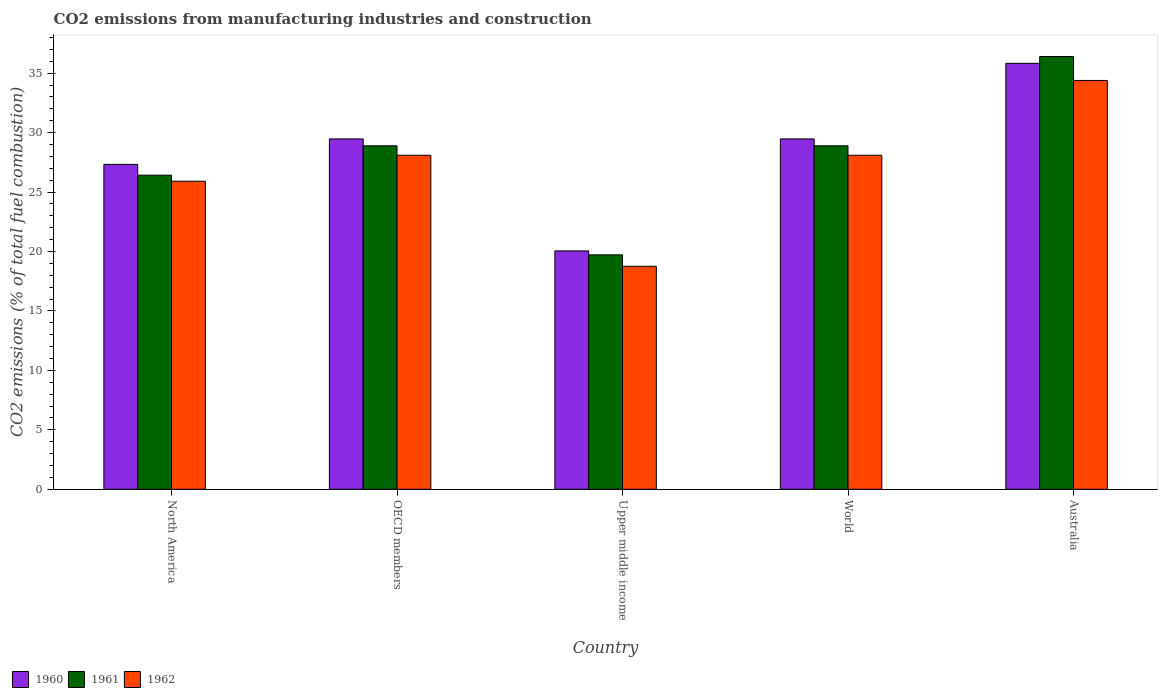How many groups of bars are there?
Keep it short and to the point. 5. Are the number of bars per tick equal to the number of legend labels?
Offer a terse response. Yes. Are the number of bars on each tick of the X-axis equal?
Your response must be concise. Yes. What is the amount of CO2 emitted in 1960 in Upper middle income?
Offer a terse response. 20.05. Across all countries, what is the maximum amount of CO2 emitted in 1961?
Give a very brief answer. 36.4. Across all countries, what is the minimum amount of CO2 emitted in 1961?
Give a very brief answer. 19.72. In which country was the amount of CO2 emitted in 1962 maximum?
Offer a terse response. Australia. In which country was the amount of CO2 emitted in 1960 minimum?
Your response must be concise. Upper middle income. What is the total amount of CO2 emitted in 1961 in the graph?
Your answer should be compact. 140.31. What is the difference between the amount of CO2 emitted in 1960 in Australia and that in World?
Offer a very short reply. 6.36. What is the difference between the amount of CO2 emitted in 1961 in North America and the amount of CO2 emitted in 1960 in Australia?
Your answer should be very brief. -9.41. What is the average amount of CO2 emitted in 1960 per country?
Offer a very short reply. 28.43. What is the difference between the amount of CO2 emitted of/in 1960 and amount of CO2 emitted of/in 1961 in OECD members?
Provide a succinct answer. 0.58. In how many countries, is the amount of CO2 emitted in 1961 greater than 26 %?
Make the answer very short. 4. What is the ratio of the amount of CO2 emitted in 1962 in Upper middle income to that in World?
Offer a terse response. 0.67. Is the difference between the amount of CO2 emitted in 1960 in OECD members and World greater than the difference between the amount of CO2 emitted in 1961 in OECD members and World?
Make the answer very short. No. What is the difference between the highest and the second highest amount of CO2 emitted in 1961?
Provide a short and direct response. 7.51. What is the difference between the highest and the lowest amount of CO2 emitted in 1961?
Your answer should be compact. 16.68. Is the sum of the amount of CO2 emitted in 1962 in Australia and Upper middle income greater than the maximum amount of CO2 emitted in 1961 across all countries?
Your answer should be very brief. Yes. What does the 1st bar from the right in OECD members represents?
Ensure brevity in your answer.  1962. How many countries are there in the graph?
Offer a terse response. 5. Are the values on the major ticks of Y-axis written in scientific E-notation?
Your answer should be very brief. No. Does the graph contain any zero values?
Provide a short and direct response. No. Does the graph contain grids?
Keep it short and to the point. No. How are the legend labels stacked?
Provide a short and direct response. Horizontal. What is the title of the graph?
Your answer should be very brief. CO2 emissions from manufacturing industries and construction. Does "1989" appear as one of the legend labels in the graph?
Make the answer very short. No. What is the label or title of the X-axis?
Provide a succinct answer. Country. What is the label or title of the Y-axis?
Offer a very short reply. CO2 emissions (% of total fuel combustion). What is the CO2 emissions (% of total fuel combustion) of 1960 in North America?
Your answer should be compact. 27.33. What is the CO2 emissions (% of total fuel combustion) of 1961 in North America?
Provide a short and direct response. 26.42. What is the CO2 emissions (% of total fuel combustion) of 1962 in North America?
Ensure brevity in your answer.  25.91. What is the CO2 emissions (% of total fuel combustion) of 1960 in OECD members?
Ensure brevity in your answer.  29.47. What is the CO2 emissions (% of total fuel combustion) of 1961 in OECD members?
Offer a very short reply. 28.89. What is the CO2 emissions (% of total fuel combustion) in 1962 in OECD members?
Your answer should be compact. 28.09. What is the CO2 emissions (% of total fuel combustion) in 1960 in Upper middle income?
Offer a terse response. 20.05. What is the CO2 emissions (% of total fuel combustion) of 1961 in Upper middle income?
Provide a short and direct response. 19.72. What is the CO2 emissions (% of total fuel combustion) in 1962 in Upper middle income?
Your answer should be very brief. 18.76. What is the CO2 emissions (% of total fuel combustion) of 1960 in World?
Offer a terse response. 29.47. What is the CO2 emissions (% of total fuel combustion) in 1961 in World?
Your answer should be very brief. 28.89. What is the CO2 emissions (% of total fuel combustion) of 1962 in World?
Provide a succinct answer. 28.09. What is the CO2 emissions (% of total fuel combustion) in 1960 in Australia?
Provide a short and direct response. 35.83. What is the CO2 emissions (% of total fuel combustion) in 1961 in Australia?
Provide a succinct answer. 36.4. What is the CO2 emissions (% of total fuel combustion) of 1962 in Australia?
Ensure brevity in your answer.  34.39. Across all countries, what is the maximum CO2 emissions (% of total fuel combustion) of 1960?
Give a very brief answer. 35.83. Across all countries, what is the maximum CO2 emissions (% of total fuel combustion) of 1961?
Give a very brief answer. 36.4. Across all countries, what is the maximum CO2 emissions (% of total fuel combustion) in 1962?
Offer a very short reply. 34.39. Across all countries, what is the minimum CO2 emissions (% of total fuel combustion) in 1960?
Your answer should be very brief. 20.05. Across all countries, what is the minimum CO2 emissions (% of total fuel combustion) of 1961?
Make the answer very short. 19.72. Across all countries, what is the minimum CO2 emissions (% of total fuel combustion) in 1962?
Offer a terse response. 18.76. What is the total CO2 emissions (% of total fuel combustion) in 1960 in the graph?
Ensure brevity in your answer.  142.14. What is the total CO2 emissions (% of total fuel combustion) in 1961 in the graph?
Give a very brief answer. 140.31. What is the total CO2 emissions (% of total fuel combustion) of 1962 in the graph?
Provide a succinct answer. 135.24. What is the difference between the CO2 emissions (% of total fuel combustion) in 1960 in North America and that in OECD members?
Your answer should be compact. -2.14. What is the difference between the CO2 emissions (% of total fuel combustion) of 1961 in North America and that in OECD members?
Your response must be concise. -2.47. What is the difference between the CO2 emissions (% of total fuel combustion) of 1962 in North America and that in OECD members?
Give a very brief answer. -2.18. What is the difference between the CO2 emissions (% of total fuel combustion) in 1960 in North America and that in Upper middle income?
Provide a succinct answer. 7.28. What is the difference between the CO2 emissions (% of total fuel combustion) of 1961 in North America and that in Upper middle income?
Provide a short and direct response. 6.7. What is the difference between the CO2 emissions (% of total fuel combustion) in 1962 in North America and that in Upper middle income?
Your response must be concise. 7.15. What is the difference between the CO2 emissions (% of total fuel combustion) of 1960 in North America and that in World?
Your answer should be very brief. -2.14. What is the difference between the CO2 emissions (% of total fuel combustion) of 1961 in North America and that in World?
Your answer should be very brief. -2.47. What is the difference between the CO2 emissions (% of total fuel combustion) of 1962 in North America and that in World?
Your answer should be very brief. -2.18. What is the difference between the CO2 emissions (% of total fuel combustion) of 1960 in North America and that in Australia?
Keep it short and to the point. -8.5. What is the difference between the CO2 emissions (% of total fuel combustion) in 1961 in North America and that in Australia?
Your answer should be very brief. -9.98. What is the difference between the CO2 emissions (% of total fuel combustion) in 1962 in North America and that in Australia?
Make the answer very short. -8.47. What is the difference between the CO2 emissions (% of total fuel combustion) of 1960 in OECD members and that in Upper middle income?
Offer a terse response. 9.42. What is the difference between the CO2 emissions (% of total fuel combustion) in 1961 in OECD members and that in Upper middle income?
Provide a succinct answer. 9.17. What is the difference between the CO2 emissions (% of total fuel combustion) in 1962 in OECD members and that in Upper middle income?
Your answer should be compact. 9.34. What is the difference between the CO2 emissions (% of total fuel combustion) in 1960 in OECD members and that in World?
Provide a short and direct response. 0. What is the difference between the CO2 emissions (% of total fuel combustion) of 1962 in OECD members and that in World?
Ensure brevity in your answer.  0. What is the difference between the CO2 emissions (% of total fuel combustion) in 1960 in OECD members and that in Australia?
Your answer should be compact. -6.36. What is the difference between the CO2 emissions (% of total fuel combustion) in 1961 in OECD members and that in Australia?
Provide a succinct answer. -7.51. What is the difference between the CO2 emissions (% of total fuel combustion) in 1962 in OECD members and that in Australia?
Offer a terse response. -6.29. What is the difference between the CO2 emissions (% of total fuel combustion) in 1960 in Upper middle income and that in World?
Provide a succinct answer. -9.42. What is the difference between the CO2 emissions (% of total fuel combustion) in 1961 in Upper middle income and that in World?
Give a very brief answer. -9.17. What is the difference between the CO2 emissions (% of total fuel combustion) of 1962 in Upper middle income and that in World?
Make the answer very short. -9.34. What is the difference between the CO2 emissions (% of total fuel combustion) in 1960 in Upper middle income and that in Australia?
Ensure brevity in your answer.  -15.78. What is the difference between the CO2 emissions (% of total fuel combustion) in 1961 in Upper middle income and that in Australia?
Your answer should be compact. -16.68. What is the difference between the CO2 emissions (% of total fuel combustion) in 1962 in Upper middle income and that in Australia?
Ensure brevity in your answer.  -15.63. What is the difference between the CO2 emissions (% of total fuel combustion) of 1960 in World and that in Australia?
Keep it short and to the point. -6.36. What is the difference between the CO2 emissions (% of total fuel combustion) of 1961 in World and that in Australia?
Your answer should be very brief. -7.51. What is the difference between the CO2 emissions (% of total fuel combustion) of 1962 in World and that in Australia?
Make the answer very short. -6.29. What is the difference between the CO2 emissions (% of total fuel combustion) in 1960 in North America and the CO2 emissions (% of total fuel combustion) in 1961 in OECD members?
Ensure brevity in your answer.  -1.56. What is the difference between the CO2 emissions (% of total fuel combustion) of 1960 in North America and the CO2 emissions (% of total fuel combustion) of 1962 in OECD members?
Your answer should be compact. -0.77. What is the difference between the CO2 emissions (% of total fuel combustion) in 1961 in North America and the CO2 emissions (% of total fuel combustion) in 1962 in OECD members?
Give a very brief answer. -1.67. What is the difference between the CO2 emissions (% of total fuel combustion) of 1960 in North America and the CO2 emissions (% of total fuel combustion) of 1961 in Upper middle income?
Provide a succinct answer. 7.61. What is the difference between the CO2 emissions (% of total fuel combustion) of 1960 in North America and the CO2 emissions (% of total fuel combustion) of 1962 in Upper middle income?
Give a very brief answer. 8.57. What is the difference between the CO2 emissions (% of total fuel combustion) in 1961 in North America and the CO2 emissions (% of total fuel combustion) in 1962 in Upper middle income?
Give a very brief answer. 7.66. What is the difference between the CO2 emissions (% of total fuel combustion) in 1960 in North America and the CO2 emissions (% of total fuel combustion) in 1961 in World?
Offer a terse response. -1.56. What is the difference between the CO2 emissions (% of total fuel combustion) of 1960 in North America and the CO2 emissions (% of total fuel combustion) of 1962 in World?
Provide a succinct answer. -0.77. What is the difference between the CO2 emissions (% of total fuel combustion) in 1961 in North America and the CO2 emissions (% of total fuel combustion) in 1962 in World?
Provide a short and direct response. -1.67. What is the difference between the CO2 emissions (% of total fuel combustion) in 1960 in North America and the CO2 emissions (% of total fuel combustion) in 1961 in Australia?
Make the answer very short. -9.07. What is the difference between the CO2 emissions (% of total fuel combustion) of 1960 in North America and the CO2 emissions (% of total fuel combustion) of 1962 in Australia?
Your answer should be compact. -7.06. What is the difference between the CO2 emissions (% of total fuel combustion) of 1961 in North America and the CO2 emissions (% of total fuel combustion) of 1962 in Australia?
Provide a succinct answer. -7.97. What is the difference between the CO2 emissions (% of total fuel combustion) in 1960 in OECD members and the CO2 emissions (% of total fuel combustion) in 1961 in Upper middle income?
Make the answer very short. 9.75. What is the difference between the CO2 emissions (% of total fuel combustion) in 1960 in OECD members and the CO2 emissions (% of total fuel combustion) in 1962 in Upper middle income?
Ensure brevity in your answer.  10.71. What is the difference between the CO2 emissions (% of total fuel combustion) of 1961 in OECD members and the CO2 emissions (% of total fuel combustion) of 1962 in Upper middle income?
Offer a terse response. 10.13. What is the difference between the CO2 emissions (% of total fuel combustion) in 1960 in OECD members and the CO2 emissions (% of total fuel combustion) in 1961 in World?
Your answer should be very brief. 0.58. What is the difference between the CO2 emissions (% of total fuel combustion) of 1960 in OECD members and the CO2 emissions (% of total fuel combustion) of 1962 in World?
Ensure brevity in your answer.  1.38. What is the difference between the CO2 emissions (% of total fuel combustion) in 1961 in OECD members and the CO2 emissions (% of total fuel combustion) in 1962 in World?
Your answer should be compact. 0.79. What is the difference between the CO2 emissions (% of total fuel combustion) in 1960 in OECD members and the CO2 emissions (% of total fuel combustion) in 1961 in Australia?
Provide a succinct answer. -6.93. What is the difference between the CO2 emissions (% of total fuel combustion) of 1960 in OECD members and the CO2 emissions (% of total fuel combustion) of 1962 in Australia?
Provide a succinct answer. -4.92. What is the difference between the CO2 emissions (% of total fuel combustion) of 1961 in OECD members and the CO2 emissions (% of total fuel combustion) of 1962 in Australia?
Your response must be concise. -5.5. What is the difference between the CO2 emissions (% of total fuel combustion) of 1960 in Upper middle income and the CO2 emissions (% of total fuel combustion) of 1961 in World?
Ensure brevity in your answer.  -8.84. What is the difference between the CO2 emissions (% of total fuel combustion) of 1960 in Upper middle income and the CO2 emissions (% of total fuel combustion) of 1962 in World?
Provide a short and direct response. -8.04. What is the difference between the CO2 emissions (% of total fuel combustion) of 1961 in Upper middle income and the CO2 emissions (% of total fuel combustion) of 1962 in World?
Offer a terse response. -8.38. What is the difference between the CO2 emissions (% of total fuel combustion) in 1960 in Upper middle income and the CO2 emissions (% of total fuel combustion) in 1961 in Australia?
Your response must be concise. -16.35. What is the difference between the CO2 emissions (% of total fuel combustion) in 1960 in Upper middle income and the CO2 emissions (% of total fuel combustion) in 1962 in Australia?
Your answer should be very brief. -14.34. What is the difference between the CO2 emissions (% of total fuel combustion) in 1961 in Upper middle income and the CO2 emissions (% of total fuel combustion) in 1962 in Australia?
Provide a short and direct response. -14.67. What is the difference between the CO2 emissions (% of total fuel combustion) of 1960 in World and the CO2 emissions (% of total fuel combustion) of 1961 in Australia?
Ensure brevity in your answer.  -6.93. What is the difference between the CO2 emissions (% of total fuel combustion) of 1960 in World and the CO2 emissions (% of total fuel combustion) of 1962 in Australia?
Your response must be concise. -4.92. What is the difference between the CO2 emissions (% of total fuel combustion) of 1961 in World and the CO2 emissions (% of total fuel combustion) of 1962 in Australia?
Offer a terse response. -5.5. What is the average CO2 emissions (% of total fuel combustion) of 1960 per country?
Provide a short and direct response. 28.43. What is the average CO2 emissions (% of total fuel combustion) of 1961 per country?
Keep it short and to the point. 28.06. What is the average CO2 emissions (% of total fuel combustion) of 1962 per country?
Ensure brevity in your answer.  27.05. What is the difference between the CO2 emissions (% of total fuel combustion) of 1960 and CO2 emissions (% of total fuel combustion) of 1961 in North America?
Ensure brevity in your answer.  0.91. What is the difference between the CO2 emissions (% of total fuel combustion) of 1960 and CO2 emissions (% of total fuel combustion) of 1962 in North America?
Provide a succinct answer. 1.42. What is the difference between the CO2 emissions (% of total fuel combustion) of 1961 and CO2 emissions (% of total fuel combustion) of 1962 in North America?
Give a very brief answer. 0.51. What is the difference between the CO2 emissions (% of total fuel combustion) of 1960 and CO2 emissions (% of total fuel combustion) of 1961 in OECD members?
Ensure brevity in your answer.  0.58. What is the difference between the CO2 emissions (% of total fuel combustion) in 1960 and CO2 emissions (% of total fuel combustion) in 1962 in OECD members?
Offer a terse response. 1.38. What is the difference between the CO2 emissions (% of total fuel combustion) of 1961 and CO2 emissions (% of total fuel combustion) of 1962 in OECD members?
Offer a terse response. 0.79. What is the difference between the CO2 emissions (% of total fuel combustion) in 1960 and CO2 emissions (% of total fuel combustion) in 1961 in Upper middle income?
Make the answer very short. 0.33. What is the difference between the CO2 emissions (% of total fuel combustion) of 1960 and CO2 emissions (% of total fuel combustion) of 1962 in Upper middle income?
Offer a very short reply. 1.29. What is the difference between the CO2 emissions (% of total fuel combustion) in 1961 and CO2 emissions (% of total fuel combustion) in 1962 in Upper middle income?
Your response must be concise. 0.96. What is the difference between the CO2 emissions (% of total fuel combustion) in 1960 and CO2 emissions (% of total fuel combustion) in 1961 in World?
Your response must be concise. 0.58. What is the difference between the CO2 emissions (% of total fuel combustion) of 1960 and CO2 emissions (% of total fuel combustion) of 1962 in World?
Provide a succinct answer. 1.38. What is the difference between the CO2 emissions (% of total fuel combustion) in 1961 and CO2 emissions (% of total fuel combustion) in 1962 in World?
Your response must be concise. 0.79. What is the difference between the CO2 emissions (% of total fuel combustion) of 1960 and CO2 emissions (% of total fuel combustion) of 1961 in Australia?
Your answer should be very brief. -0.57. What is the difference between the CO2 emissions (% of total fuel combustion) of 1960 and CO2 emissions (% of total fuel combustion) of 1962 in Australia?
Your answer should be compact. 1.44. What is the difference between the CO2 emissions (% of total fuel combustion) of 1961 and CO2 emissions (% of total fuel combustion) of 1962 in Australia?
Your response must be concise. 2.01. What is the ratio of the CO2 emissions (% of total fuel combustion) in 1960 in North America to that in OECD members?
Offer a terse response. 0.93. What is the ratio of the CO2 emissions (% of total fuel combustion) of 1961 in North America to that in OECD members?
Offer a terse response. 0.91. What is the ratio of the CO2 emissions (% of total fuel combustion) of 1962 in North America to that in OECD members?
Provide a succinct answer. 0.92. What is the ratio of the CO2 emissions (% of total fuel combustion) in 1960 in North America to that in Upper middle income?
Your answer should be very brief. 1.36. What is the ratio of the CO2 emissions (% of total fuel combustion) of 1961 in North America to that in Upper middle income?
Your response must be concise. 1.34. What is the ratio of the CO2 emissions (% of total fuel combustion) of 1962 in North America to that in Upper middle income?
Offer a very short reply. 1.38. What is the ratio of the CO2 emissions (% of total fuel combustion) in 1960 in North America to that in World?
Ensure brevity in your answer.  0.93. What is the ratio of the CO2 emissions (% of total fuel combustion) in 1961 in North America to that in World?
Provide a short and direct response. 0.91. What is the ratio of the CO2 emissions (% of total fuel combustion) in 1962 in North America to that in World?
Your answer should be compact. 0.92. What is the ratio of the CO2 emissions (% of total fuel combustion) in 1960 in North America to that in Australia?
Your response must be concise. 0.76. What is the ratio of the CO2 emissions (% of total fuel combustion) in 1961 in North America to that in Australia?
Your response must be concise. 0.73. What is the ratio of the CO2 emissions (% of total fuel combustion) of 1962 in North America to that in Australia?
Keep it short and to the point. 0.75. What is the ratio of the CO2 emissions (% of total fuel combustion) of 1960 in OECD members to that in Upper middle income?
Your answer should be compact. 1.47. What is the ratio of the CO2 emissions (% of total fuel combustion) of 1961 in OECD members to that in Upper middle income?
Ensure brevity in your answer.  1.47. What is the ratio of the CO2 emissions (% of total fuel combustion) in 1962 in OECD members to that in Upper middle income?
Your response must be concise. 1.5. What is the ratio of the CO2 emissions (% of total fuel combustion) of 1960 in OECD members to that in World?
Your answer should be very brief. 1. What is the ratio of the CO2 emissions (% of total fuel combustion) of 1960 in OECD members to that in Australia?
Provide a succinct answer. 0.82. What is the ratio of the CO2 emissions (% of total fuel combustion) in 1961 in OECD members to that in Australia?
Provide a succinct answer. 0.79. What is the ratio of the CO2 emissions (% of total fuel combustion) of 1962 in OECD members to that in Australia?
Make the answer very short. 0.82. What is the ratio of the CO2 emissions (% of total fuel combustion) in 1960 in Upper middle income to that in World?
Your answer should be very brief. 0.68. What is the ratio of the CO2 emissions (% of total fuel combustion) in 1961 in Upper middle income to that in World?
Your response must be concise. 0.68. What is the ratio of the CO2 emissions (% of total fuel combustion) in 1962 in Upper middle income to that in World?
Offer a very short reply. 0.67. What is the ratio of the CO2 emissions (% of total fuel combustion) of 1960 in Upper middle income to that in Australia?
Give a very brief answer. 0.56. What is the ratio of the CO2 emissions (% of total fuel combustion) in 1961 in Upper middle income to that in Australia?
Offer a very short reply. 0.54. What is the ratio of the CO2 emissions (% of total fuel combustion) in 1962 in Upper middle income to that in Australia?
Provide a succinct answer. 0.55. What is the ratio of the CO2 emissions (% of total fuel combustion) of 1960 in World to that in Australia?
Your answer should be very brief. 0.82. What is the ratio of the CO2 emissions (% of total fuel combustion) in 1961 in World to that in Australia?
Ensure brevity in your answer.  0.79. What is the ratio of the CO2 emissions (% of total fuel combustion) in 1962 in World to that in Australia?
Keep it short and to the point. 0.82. What is the difference between the highest and the second highest CO2 emissions (% of total fuel combustion) in 1960?
Provide a succinct answer. 6.36. What is the difference between the highest and the second highest CO2 emissions (% of total fuel combustion) in 1961?
Your answer should be compact. 7.51. What is the difference between the highest and the second highest CO2 emissions (% of total fuel combustion) in 1962?
Provide a succinct answer. 6.29. What is the difference between the highest and the lowest CO2 emissions (% of total fuel combustion) of 1960?
Offer a terse response. 15.78. What is the difference between the highest and the lowest CO2 emissions (% of total fuel combustion) of 1961?
Ensure brevity in your answer.  16.68. What is the difference between the highest and the lowest CO2 emissions (% of total fuel combustion) in 1962?
Provide a short and direct response. 15.63. 